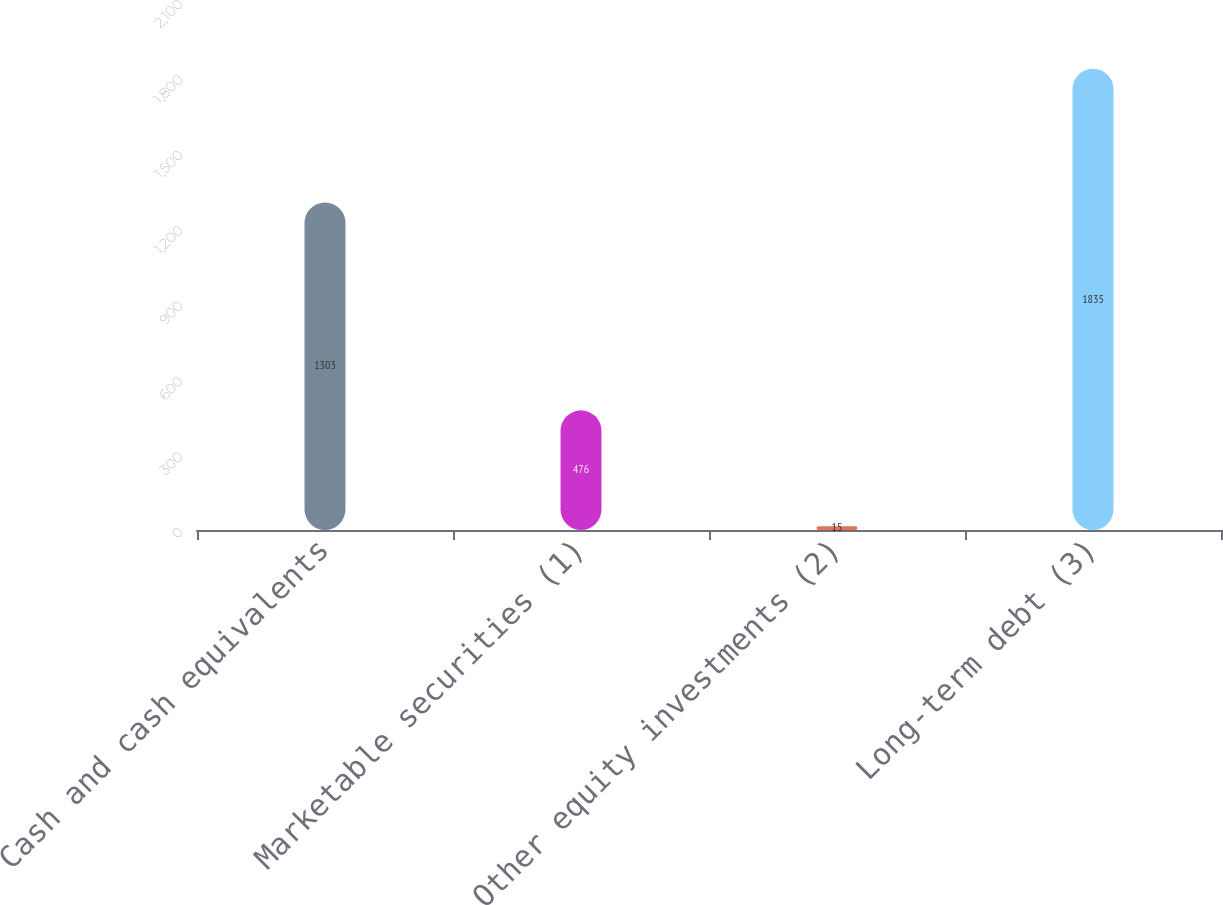Convert chart. <chart><loc_0><loc_0><loc_500><loc_500><bar_chart><fcel>Cash and cash equivalents<fcel>Marketable securities (1)<fcel>Other equity investments (2)<fcel>Long-term debt (3)<nl><fcel>1303<fcel>476<fcel>15<fcel>1835<nl></chart> 